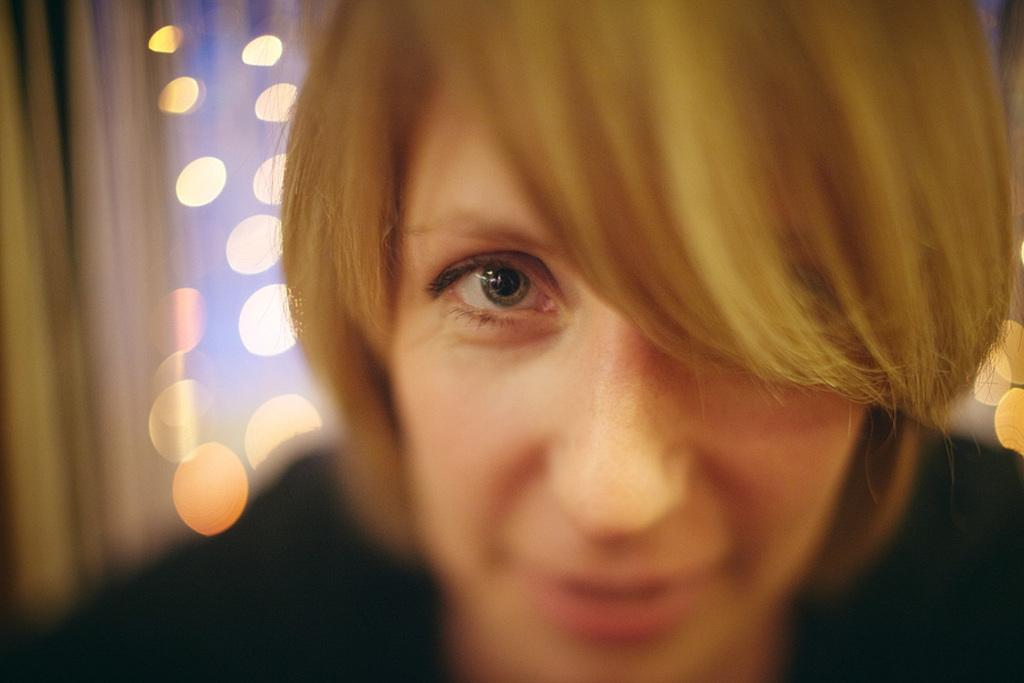Who is the main subject in the image? There is a lady in the image. What can be seen in the background of the image? There are lights in the background. How would you describe the background of the image? The background is blurry. What type of lace is the lady wearing in the image? There is no mention of lace in the image, so it cannot be determined if the lady is wearing any. 